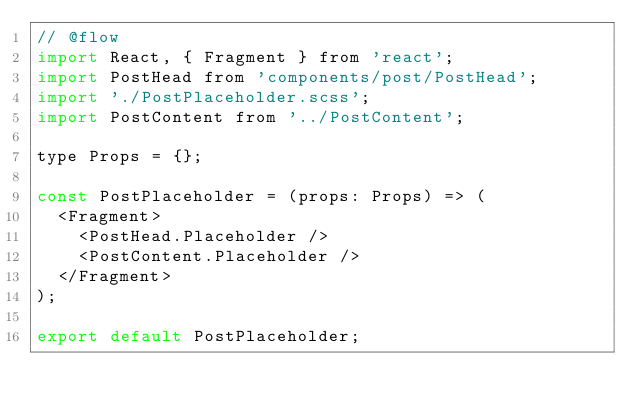Convert code to text. <code><loc_0><loc_0><loc_500><loc_500><_JavaScript_>// @flow
import React, { Fragment } from 'react';
import PostHead from 'components/post/PostHead';
import './PostPlaceholder.scss';
import PostContent from '../PostContent';

type Props = {};

const PostPlaceholder = (props: Props) => (
  <Fragment>
    <PostHead.Placeholder />
    <PostContent.Placeholder />
  </Fragment>
);

export default PostPlaceholder;
</code> 